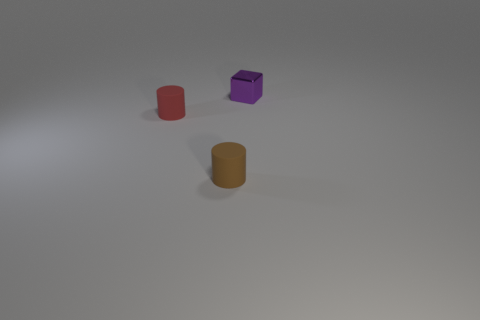Is there anything else that has the same material as the small purple block?
Keep it short and to the point. No. What is the size of the object on the left side of the rubber thing that is right of the matte thing on the left side of the small brown rubber thing?
Provide a short and direct response. Small. Do the metal object and the brown rubber thing have the same size?
Your answer should be very brief. Yes. Does the small purple thing right of the small red rubber cylinder have the same shape as the tiny thing that is in front of the small red matte cylinder?
Make the answer very short. No. Are there any cubes that are in front of the tiny rubber cylinder behind the small brown matte thing?
Give a very brief answer. No. Is there a big metal cylinder?
Provide a short and direct response. No. How many other shiny things have the same size as the metallic object?
Your response must be concise. 0. What number of things are left of the purple object and right of the red cylinder?
Make the answer very short. 1. There is a object that is to the right of the brown rubber object; does it have the same size as the brown matte object?
Make the answer very short. Yes. Is there another metal cube that has the same color as the shiny cube?
Your answer should be compact. No. 